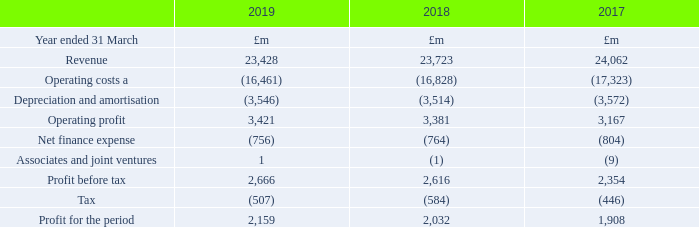Revenue
Both reported and adjusted revenue fell by 1% as growth in our Consumer business, was more than offset by regulated price reductions in Openreach and declines in our enterprise businesses in particular in fixed voice and also reflecting our strategy to reduce low margin activity such as equipment sales. Excluding the negative impact of £35m from foreign exchange movements, underlying revenue fell 0.9% (2017/18: fell 1%), which exceeds our expectation of down around 2%.
You can find details of revenue by customer-facing unit on pages 40 to 41. Note 6 to the consolidated financial statements shows a full breakdown of reported revenue by all our major product and service categories.
Operating costs
Reported operating costs were down 2% and adjustedb operating costs before depreciation and amortisation were down 1%. This was mainly driven by restructuring related cost savings and lower payments to telecommunications operators driven by Global Services strategy to de-emphasise low margin business, partly offset by higher costs of recruiting and training engineers to support Openreach’s ‘Fibre First’ programme and help deliver improved customer service.
Our cost transformation programme remains on track. c4,000 roles were removed in the year, with the largest elements being in Global Services and our Corporate Units. Overall savings from the programme are currently an annualised benefit of £875m with an associated cost of £386m. Note 7 to the consolidated financial statements shows a detailed breakdown of our operating costs.
Note 7 to the consolidated financial statements shows a detailed breakdown of our operating costs.
a Excluding depreciation and amortisation.
What was the change in the reported and adjusted revenue of Consumer business? Fell by 1%. What was the reason for change in operating costs? Mainly driven by restructuring related cost savings and lower payments to telecommunications operators driven by global services strategy to de-emphasise low margin business, partly offset by higher costs of recruiting and training engineers to support openreach’s ‘fibre first’ programme and help deliver improved customer service. What is the revenue for 2017, 2018 and 2019 respectively?
Answer scale should be: million. 24,062, 23,723, 23,428. What is the change in the revenue from 2018 to 2019?
Answer scale should be: million. 23,428 - 23,723
Answer: -295. What is the average operating costs for 2017-2019?
Answer scale should be: million. -(16,461 + 16,828 + 17,323) / 3
Answer: -16870.67. What is the average Depreciation and amortisation for 2017-2019?
Answer scale should be: million. -(3,546 + 3,514 + 3,572) / 3
Answer: -3544. 